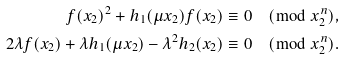<formula> <loc_0><loc_0><loc_500><loc_500>f ( x _ { 2 } ) ^ { 2 } + h _ { 1 } ( \mu x _ { 2 } ) f ( x _ { 2 } ) & \equiv 0 \pmod { x _ { 2 } ^ { n } } , \\ 2 \lambda f ( x _ { 2 } ) + \lambda h _ { 1 } ( \mu x _ { 2 } ) - \lambda ^ { 2 } h _ { 2 } ( x _ { 2 } ) & \equiv 0 \pmod { x _ { 2 } ^ { n } } .</formula> 